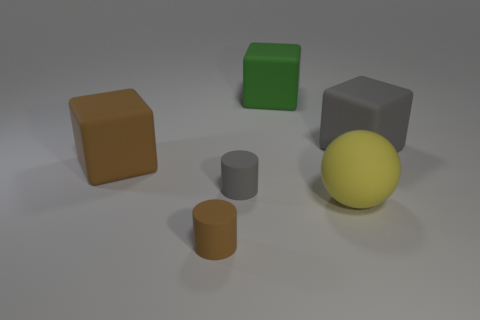What is the texture of the objects and how can I distinguish between them? In the image, there are objects with varying textures. The big sphere has a more reflective, smooth, and rubbery surface, while the blocks and cylindrical objects have a matte, non-reflective finish. These visual characteristics help distinguish their materials. 